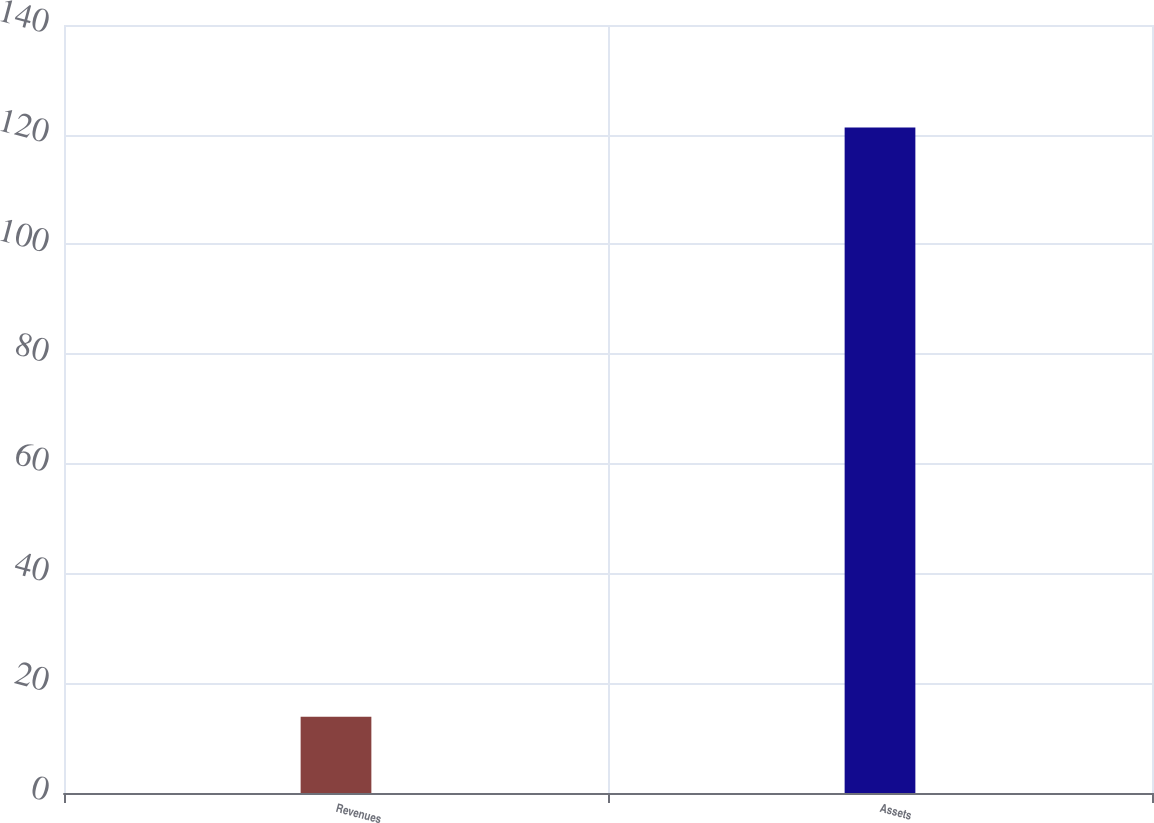<chart> <loc_0><loc_0><loc_500><loc_500><bar_chart><fcel>Revenues<fcel>Assets<nl><fcel>13.9<fcel>121.3<nl></chart> 